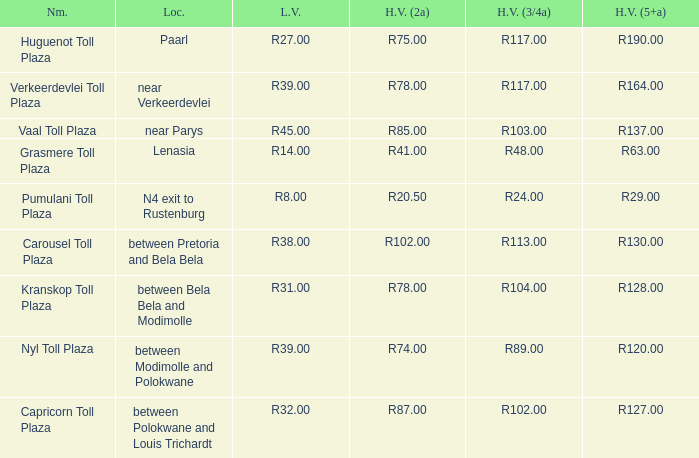What is the toll for heavy vehicles with 3/4 axles at Verkeerdevlei toll plaza? R117.00. I'm looking to parse the entire table for insights. Could you assist me with that? {'header': ['Nm.', 'Loc.', 'L.V.', 'H.V. (2a)', 'H.V. (3/4a)', 'H.V. (5+a)'], 'rows': [['Huguenot Toll Plaza', 'Paarl', 'R27.00', 'R75.00', 'R117.00', 'R190.00'], ['Verkeerdevlei Toll Plaza', 'near Verkeerdevlei', 'R39.00', 'R78.00', 'R117.00', 'R164.00'], ['Vaal Toll Plaza', 'near Parys', 'R45.00', 'R85.00', 'R103.00', 'R137.00'], ['Grasmere Toll Plaza', 'Lenasia', 'R14.00', 'R41.00', 'R48.00', 'R63.00'], ['Pumulani Toll Plaza', 'N4 exit to Rustenburg', 'R8.00', 'R20.50', 'R24.00', 'R29.00'], ['Carousel Toll Plaza', 'between Pretoria and Bela Bela', 'R38.00', 'R102.00', 'R113.00', 'R130.00'], ['Kranskop Toll Plaza', 'between Bela Bela and Modimolle', 'R31.00', 'R78.00', 'R104.00', 'R128.00'], ['Nyl Toll Plaza', 'between Modimolle and Polokwane', 'R39.00', 'R74.00', 'R89.00', 'R120.00'], ['Capricorn Toll Plaza', 'between Polokwane and Louis Trichardt', 'R32.00', 'R87.00', 'R102.00', 'R127.00']]} 